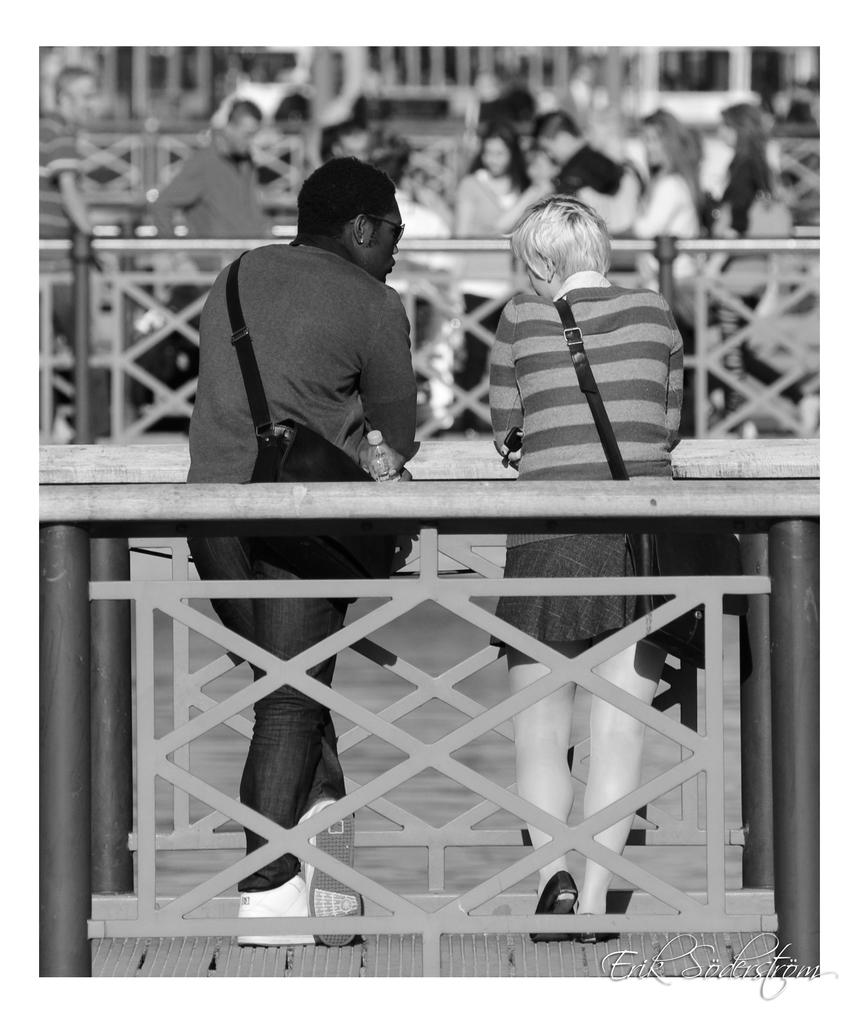How many people are present in the image? There are two people in the image. What are the two people doing in the image? The two people are carrying bags and standing on a platform. Can you describe the background of the image? There is a group of people in the background of the image, but they are blurry or out of focus. What type of coal is being used by the tiger in the image? There is no tiger present in the image, and therefore no coal or any related activity can be observed. 